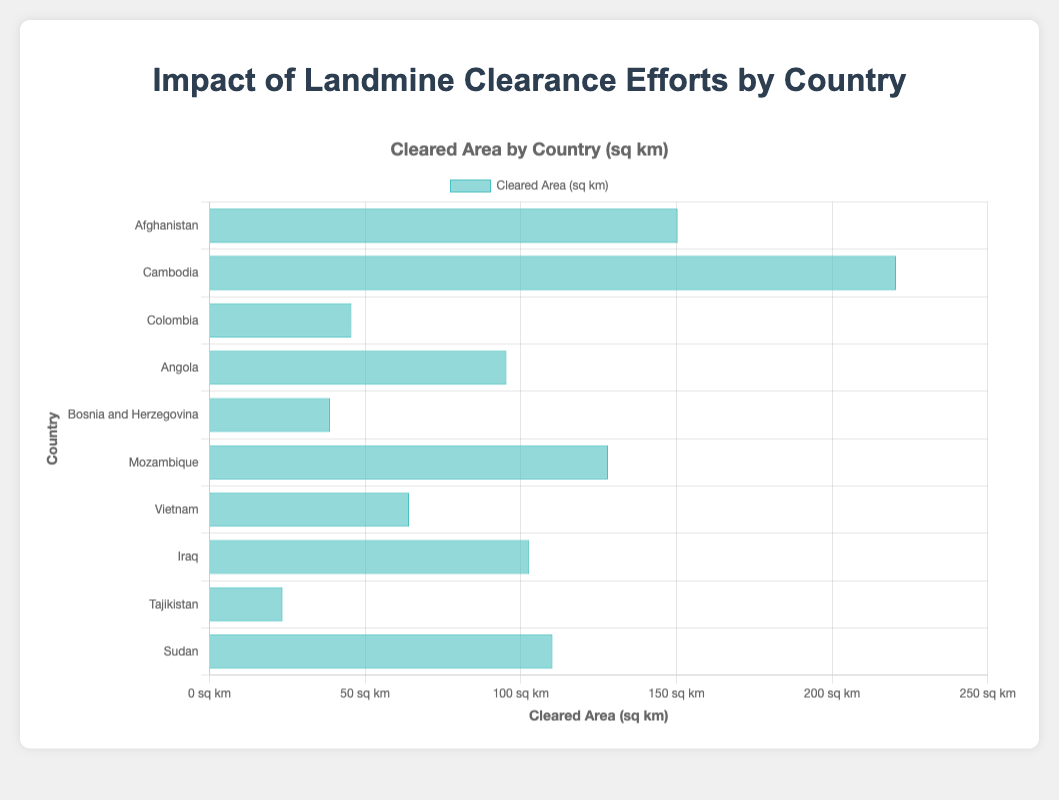What country has the largest cleared area of landmines? Look at the bar lengths in the chart. The longest bar represents Cambodia, indicating it has the largest cleared area.
Answer: Cambodia Which country has the smallest cleared area of landmines? Look for the shortest bar in the chart. It corresponds to Tajikistan, which has the smallest cleared area.
Answer: Tajikistan How much larger is Cambodia’s cleared area compared to Iraq’s? Identify the lengths of the bars for Cambodia and Iraq. Cambodia has a cleared area of 220.5 sq km, and Iraq has a cleared area of 102.7 sq km. Subtract Iraq’s value from Cambodia’s: 220.5 - 102.7 = 117.8 sq km.
Answer: 117.8 sq km Which countries have a cleared area exceeding 100 sq km? Identify bars in the chart that extend beyond the 100 sq km mark. These countries are Afghanistan, Cambodia, Mozambique, Iraq, and Sudan.
Answer: Afghanistan, Cambodia, Mozambique, Iraq, Sudan What is the total cleared area for Afghanistan, Angola, and Mozambique combined? Sum the cleared area for Afghanistan (150.3 sq km), Angola (95.4 sq km), and Mozambique (128.0 sq km): 150.3 + 95.4 + 128.0 = 373.7 sq km.
Answer: 373.7 sq km How much greater is the cleared area of Mozambique compared to Vietnam? Locate the bars for Mozambique and Vietnam. Mozambique has a cleared area of 128.0 sq km, and Vietnam has a cleared area of 64.1 sq km. Subtract Vietnam’s value from Mozambique’s: 128.0 - 64.1 = 63.9 sq km.
Answer: 63.9 sq km Which country, between Cambodia and Bosnia and Herzegovina, has a higher cleared area? Compare the bars for Cambodia and Bosnia and Herzegovina. Cambodia's bar is much longer, indicating a higher cleared area.
Answer: Cambodia Rank the countries from largest to smallest based on their cleared area. Order the countries by the lengths of their bars, from longest to shortest: Cambodia, Afghanistan, Mozambique, Iraq, Sudan, Angola, Vietnam, Colombia, Bosnia and Herzegovina, Tajikistan.
Answer: Cambodia, Afghanistan, Mozambique, Iraq, Sudan, Angola, Vietnam, Colombia, Bosnia and Herzegovina, Tajikistan If we combine the cleared areas of Angola and Tajikistan, how does the cumulative value compare to Sudan's cleared area? Calculate the sum of Angola’s (95.4 sq km) and Tajikistan’s (23.5 sq km) cleared areas: 95.4 + 23.5 = 118.9 sq km. Compare this to Sudan’s cleared area of 110.2 sq km: 118.9 > 110.2, so the combined value is greater.
Answer: Greater What is the average cleared area among all the countries listed? Sum all the cleared areas and divide by the number of countries. Total cleared areas: 150.3 + 220.5 + 45.6 + 95.4 + 38.7 + 128.0 + 64.1 + 102.7 + 23.5 + 110.2 = 979.0 sq km. Number of countries: 10. Average = 979.0 / 10 = 97.9 sq km.
Answer: 97.9 sq km 